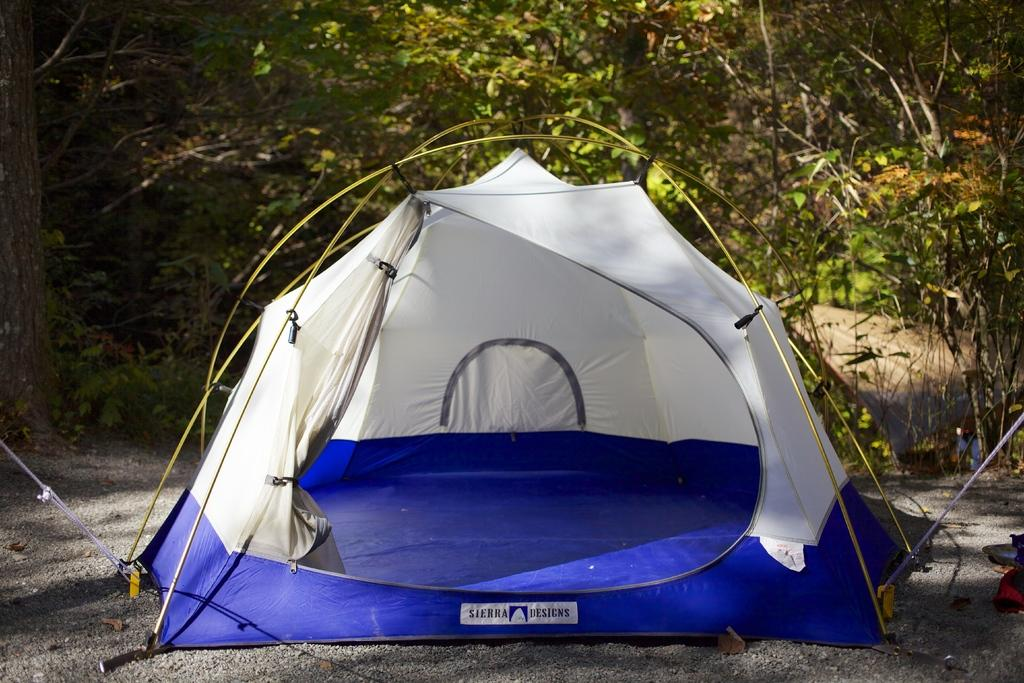What type of shelter is present in the image? There is a camping tent in the image. How are the tent and its ropes connected? The tent has ropes attached to it. On what surface is the tent placed? The tent is on a surface. What can be seen in the background of the image? There are leaves visible in the background of the image. What type of trouble can be seen in the image? There is no trouble present in the image; it features a camping tent with ropes and a background of leaves. What type of clover is growing near the tent in the image? There is no clover present in the image; it features a camping tent with ropes and a background of leaves. 